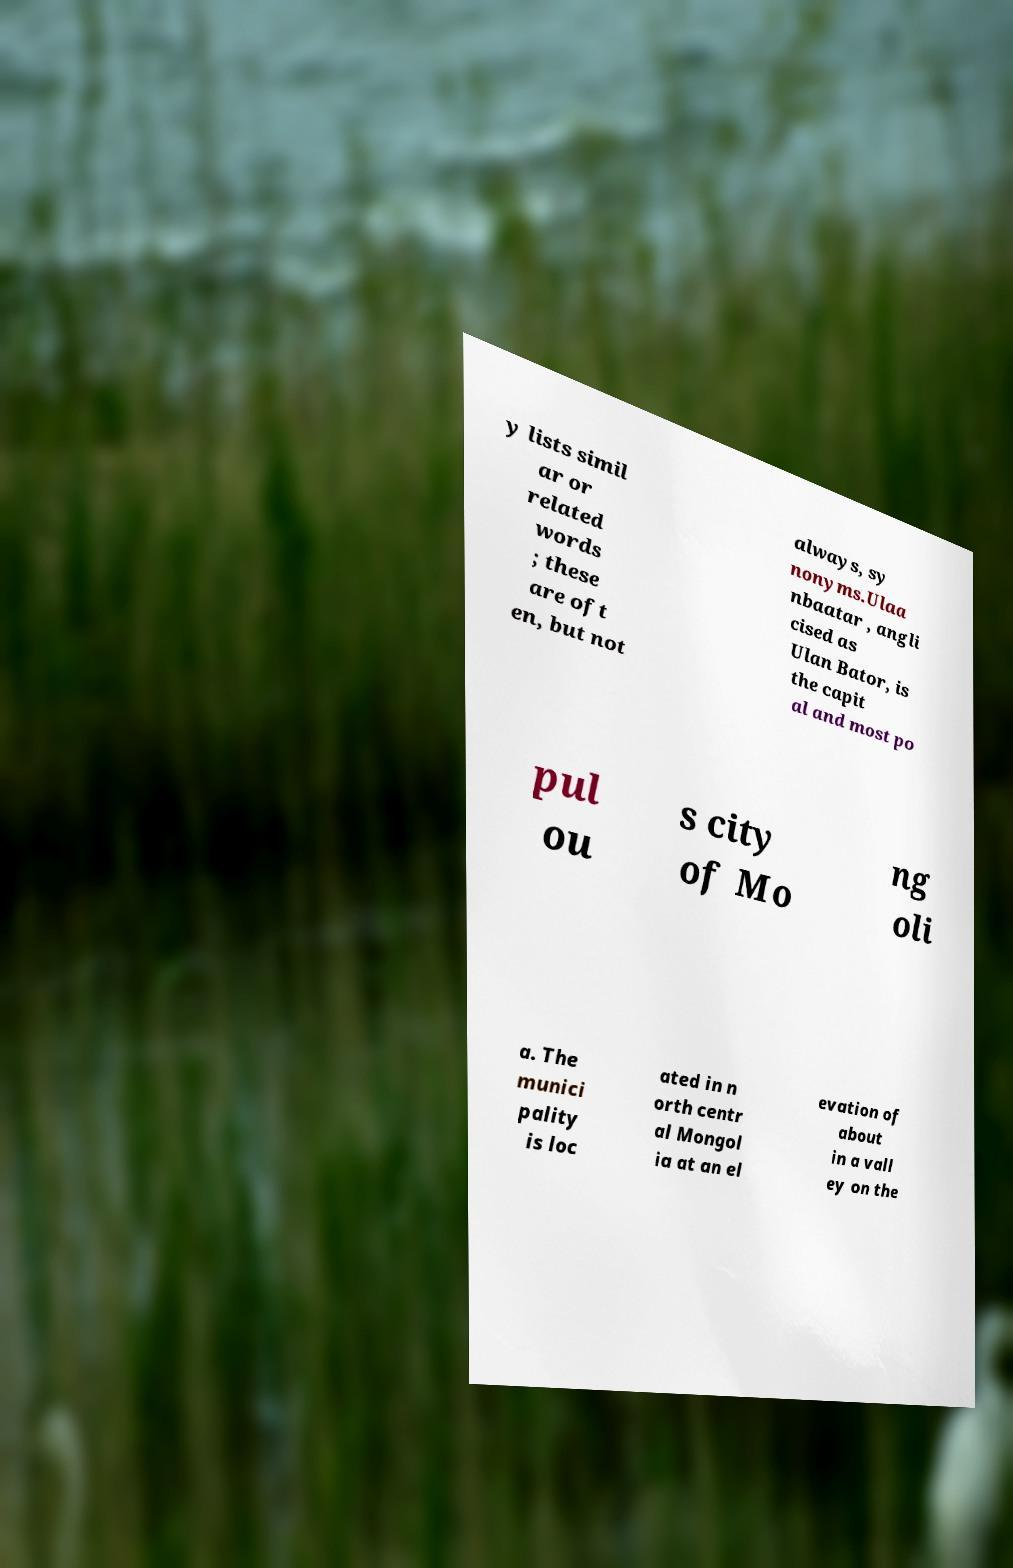Please identify and transcribe the text found in this image. y lists simil ar or related words ; these are oft en, but not always, sy nonyms.Ulaa nbaatar , angli cised as Ulan Bator, is the capit al and most po pul ou s city of Mo ng oli a. The munici pality is loc ated in n orth centr al Mongol ia at an el evation of about in a vall ey on the 